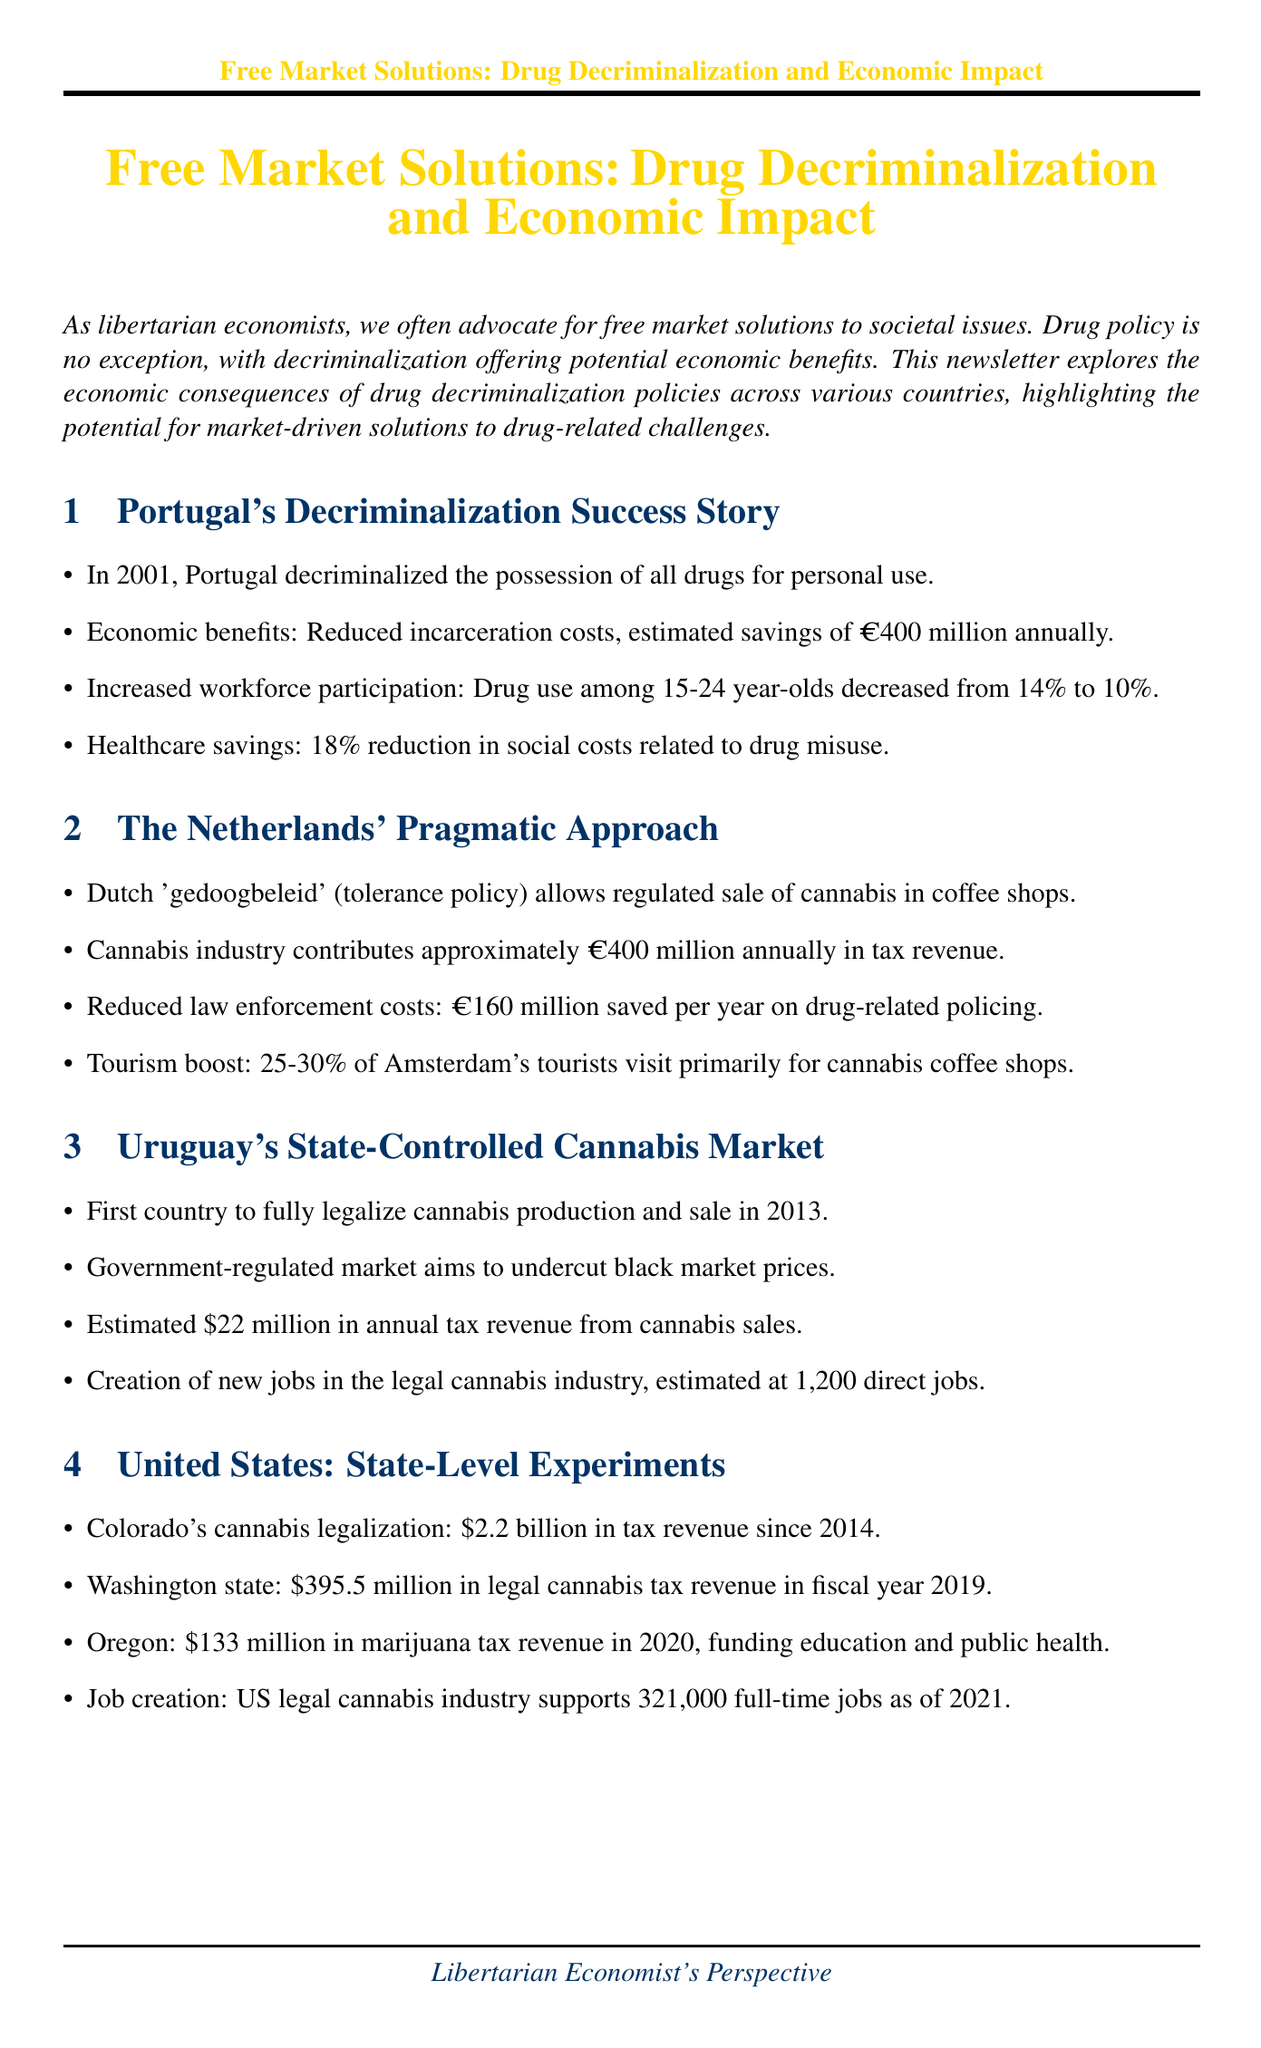What year did Portugal decriminalize drugs? The document states that Portugal decriminalized the possession of all drugs for personal use in 2001.
Answer: 2001 What is the estimated annual savings in incarceration costs for Portugal? The document mentions that Portugal achieved estimated savings of €400 million annually in incarceration costs.
Answer: €400 million How much tax revenue does the cannabis industry contribute in the Netherlands? The newsletter states that the cannabis industry in the Netherlands contributes approximately €400 million annually in tax revenue.
Answer: €400 million What was the job creation estimate in Uruguay's legal cannabis industry? The document mentions the creation of approximately 1,200 direct jobs in Uruguay's legal cannabis industry.
Answer: 1,200 What is the total tax revenue from Colorado's cannabis legalization since 2014? The document indicates that Colorado has generated $2.2 billion in tax revenue since 2014 from cannabis legalization.
Answer: $2.2 billion How much did Washington state earn in legal cannabis tax revenue in fiscal year 2019? According to the newsletter, Washington state earned $395.5 million in legal cannabis tax revenue in fiscal year 2019.
Answer: $395.5 million What is one of the proposed policy recommendations for drug decriminalization? The document lists implementing full decriminalization of drug possession for personal use as a policy recommendation.
Answer: Full decriminalization of drug possession for personal use What principle aligns drug decriminalization policies according to the conclusion? The conclusion states that drug decriminalization policies align with libertarian principles of personal freedom and market efficiency.
Answer: Personal freedom and market efficiency 